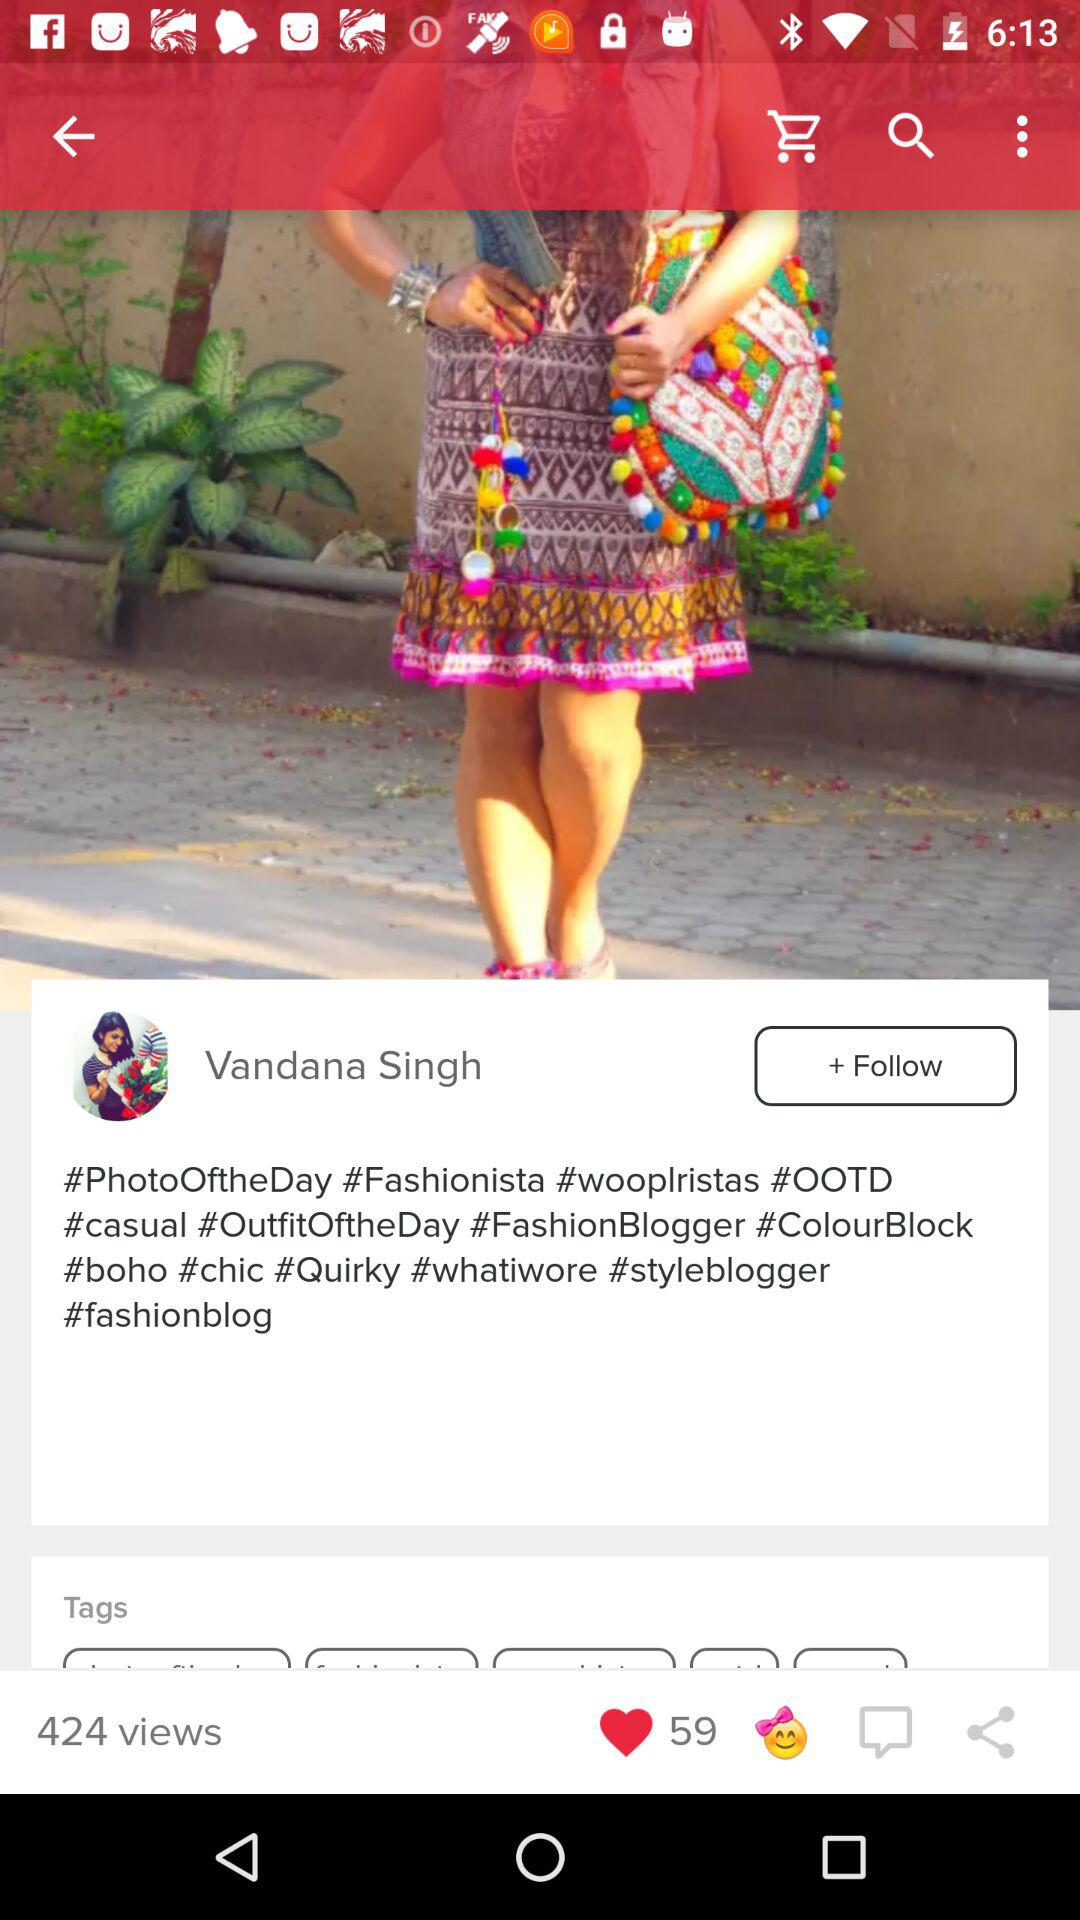How many likes are there? There are 59 likes. 